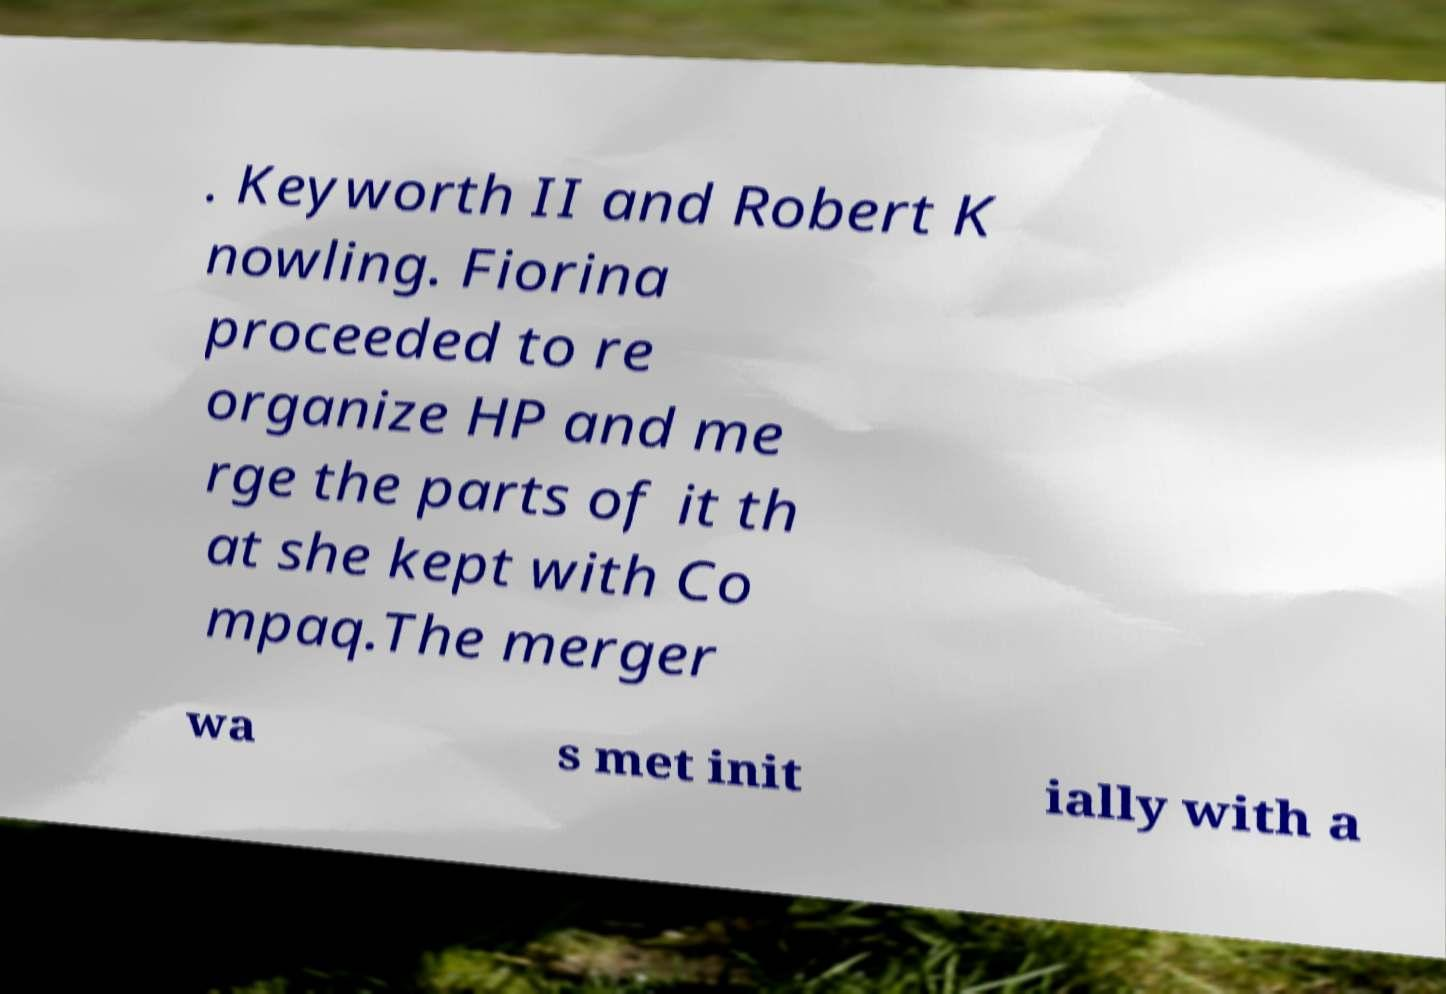Can you accurately transcribe the text from the provided image for me? . Keyworth II and Robert K nowling. Fiorina proceeded to re organize HP and me rge the parts of it th at she kept with Co mpaq.The merger wa s met init ially with a 